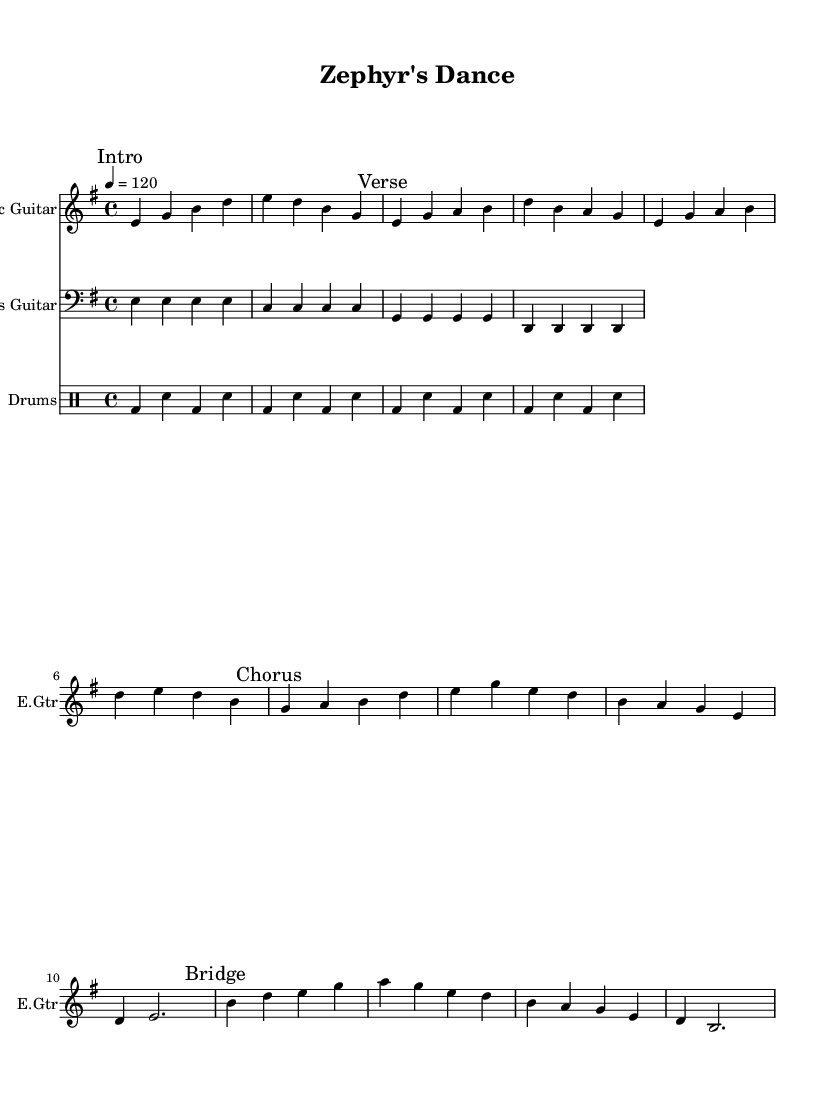What is the key signature of this music? The key signature is E minor, which has one sharp (F#). This can be identified from the key signature marking placed at the beginning of the staff.
Answer: E minor What is the time signature of this music? The time signature is 4/4, which is indicated at the beginning of the composition. It shows that there are four beats in each measure and the quarter note gets one beat.
Answer: 4/4 What is the tempo marking of this music? The tempo marking is "4 = 120", which indicates the beats per minute. This means that the quarter note should be played at 120 beats per minute.
Answer: 120 What instruments are featured in this composition? The instruments featured are electric guitar, bass guitar, and drums, as indicated in their respective staff titles at the beginning of each line.
Answer: Electric Guitar, Bass Guitar, Drums How many measures are there in the verse section? The verse section consists of four measures, which can be counted from the notes laid out under the "Verse" marking in the staff.
Answer: 4 What note serves as the first note of the chorus? The first note of the chorus is G, which can be identified as the first note in the measure immediately following the "Chorus" marking.
Answer: G How does the bass line relate to the electric guitar in the intro? The bass line primarily plays the root notes of the chords played by the electric guitar, aligning rhythmically with the guitar's introductory phrases to support harmonically.
Answer: Root notes 